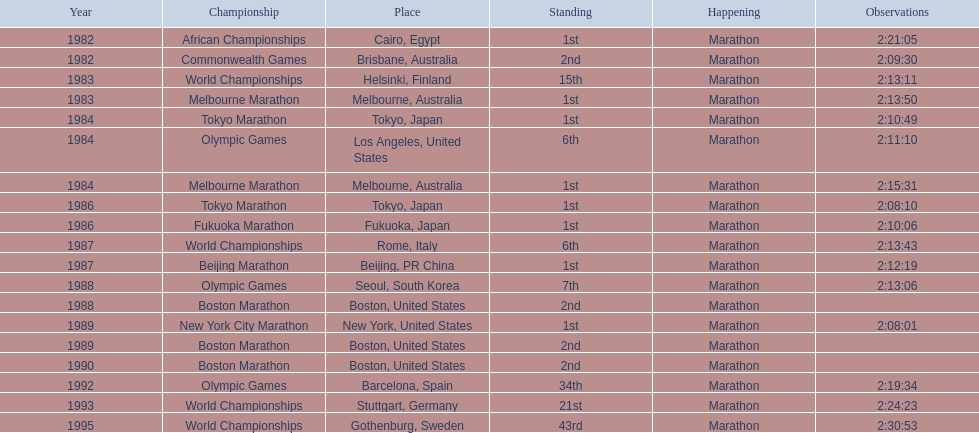What are all the competitions? African Championships, Commonwealth Games, World Championships, Melbourne Marathon, Tokyo Marathon, Olympic Games, Melbourne Marathon, Tokyo Marathon, Fukuoka Marathon, World Championships, Beijing Marathon, Olympic Games, Boston Marathon, New York City Marathon, Boston Marathon, Boston Marathon, Olympic Games, World Championships, World Championships. Where were they located? Cairo, Egypt, Brisbane, Australia, Helsinki, Finland, Melbourne, Australia, Tokyo, Japan, Los Angeles, United States, Melbourne, Australia, Tokyo, Japan, Fukuoka, Japan, Rome, Italy, Beijing, PR China, Seoul, South Korea, Boston, United States, New York, United States, Boston, United States, Boston, United States, Barcelona, Spain, Stuttgart, Germany, Gothenburg, Sweden. And which competition was in china? Beijing Marathon. 